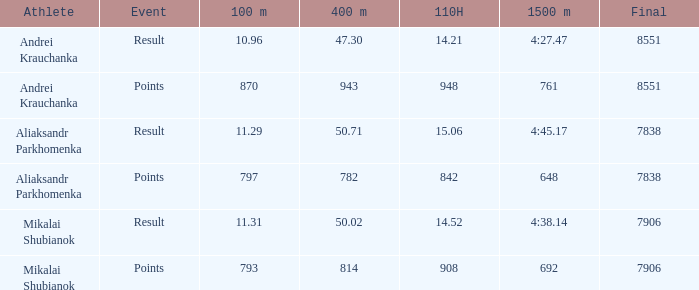What was the 400m that had a 110H greater than 14.21, a final of more than 7838, and having result in events? 1.0. 